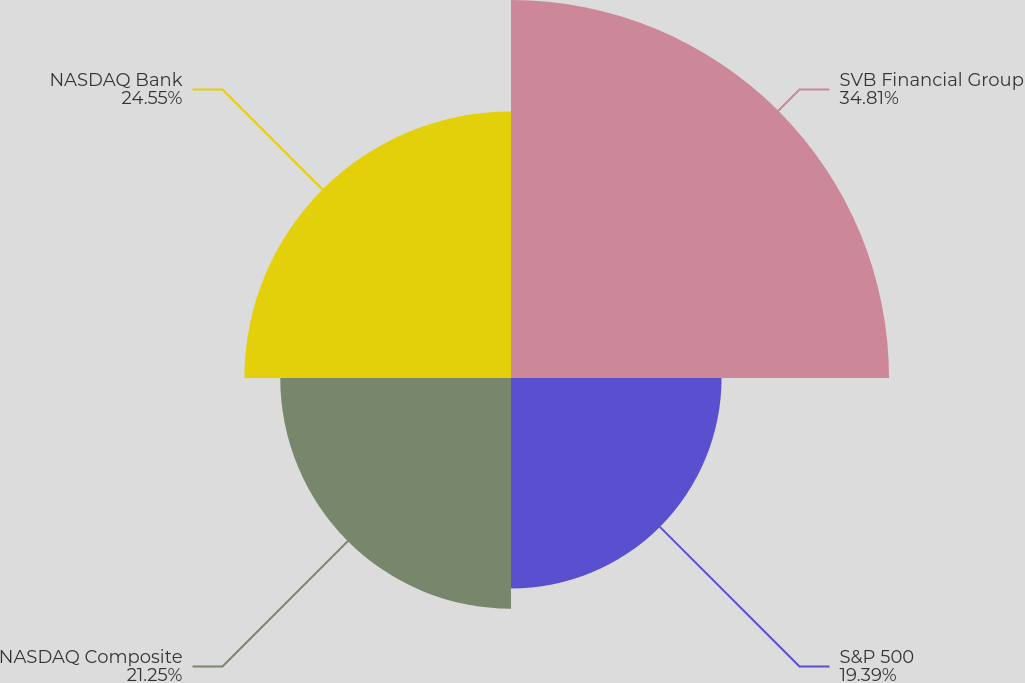Convert chart to OTSL. <chart><loc_0><loc_0><loc_500><loc_500><pie_chart><fcel>SVB Financial Group<fcel>S&P 500<fcel>NASDAQ Composite<fcel>NASDAQ Bank<nl><fcel>34.81%<fcel>19.39%<fcel>21.25%<fcel>24.55%<nl></chart> 